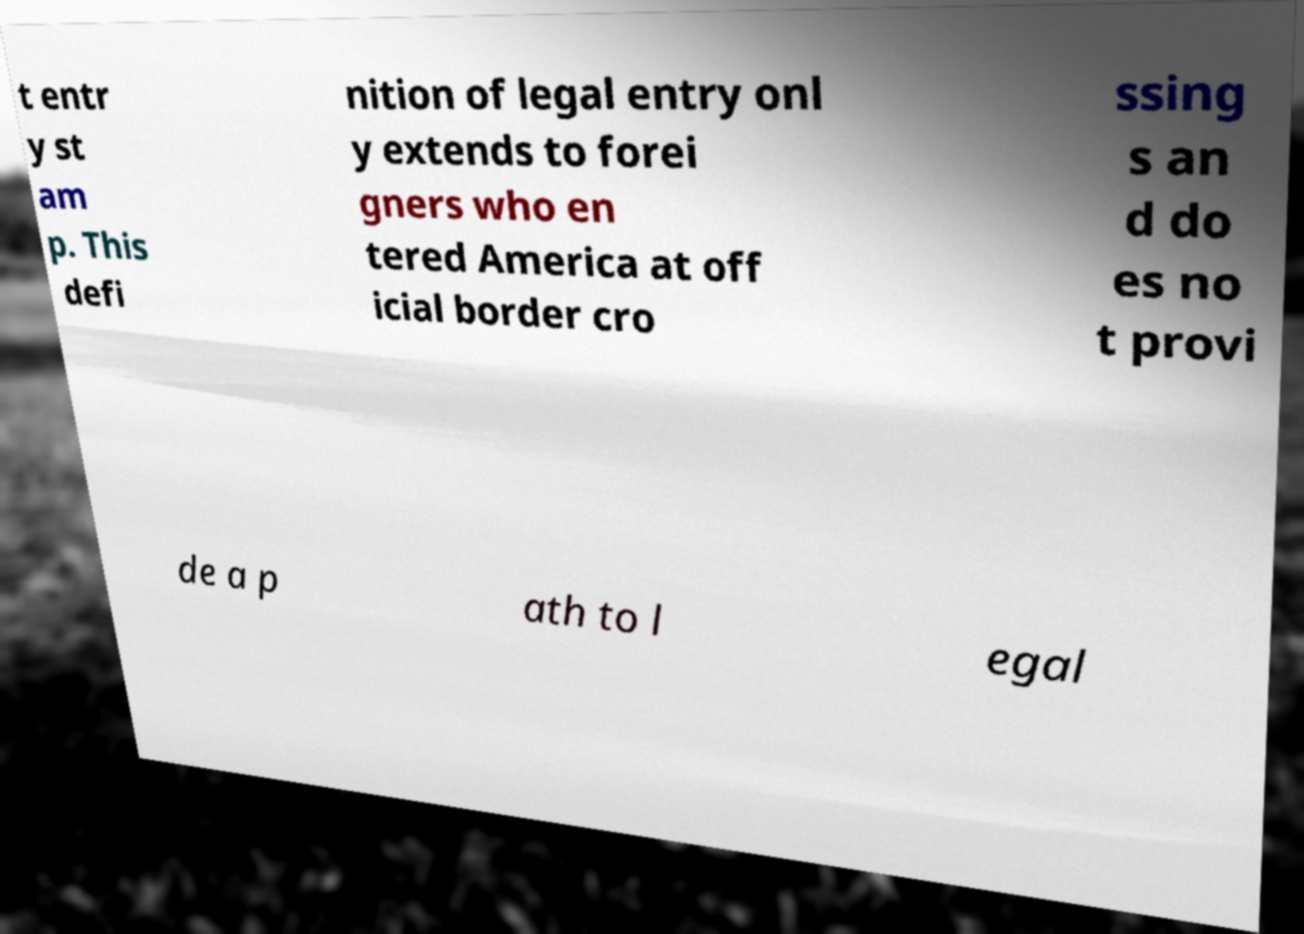What messages or text are displayed in this image? I need them in a readable, typed format. t entr y st am p. This defi nition of legal entry onl y extends to forei gners who en tered America at off icial border cro ssing s an d do es no t provi de a p ath to l egal 